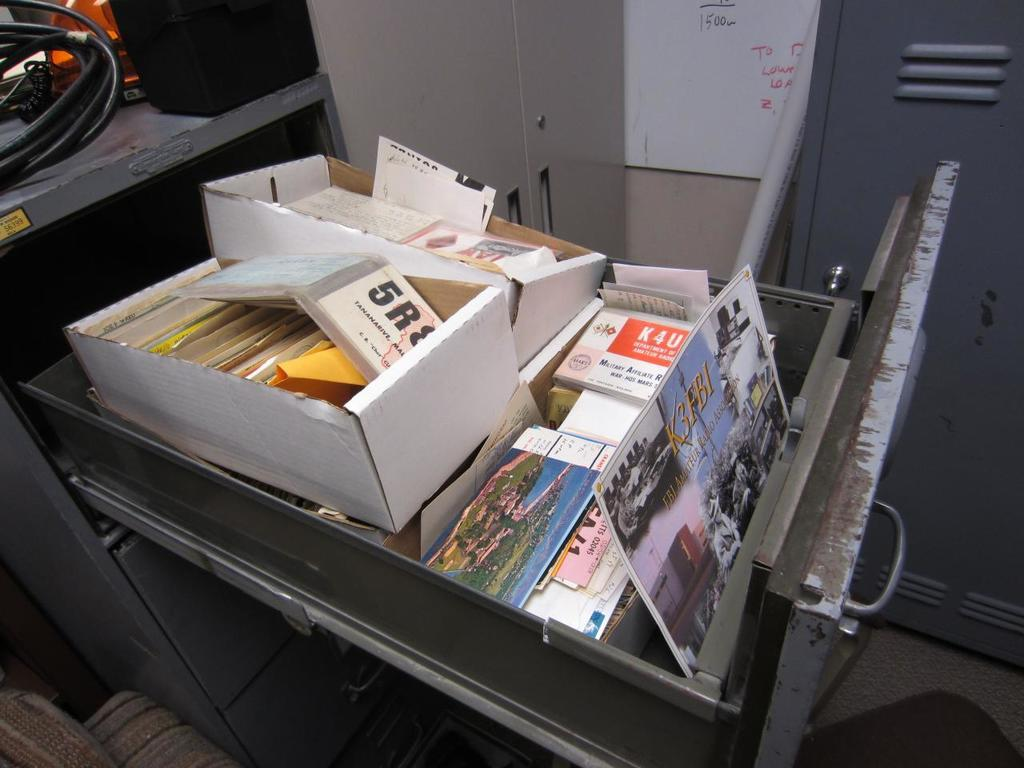Provide a one-sentence caption for the provided image. a filing cabinet is full of papers including one about Amateur Radio. 